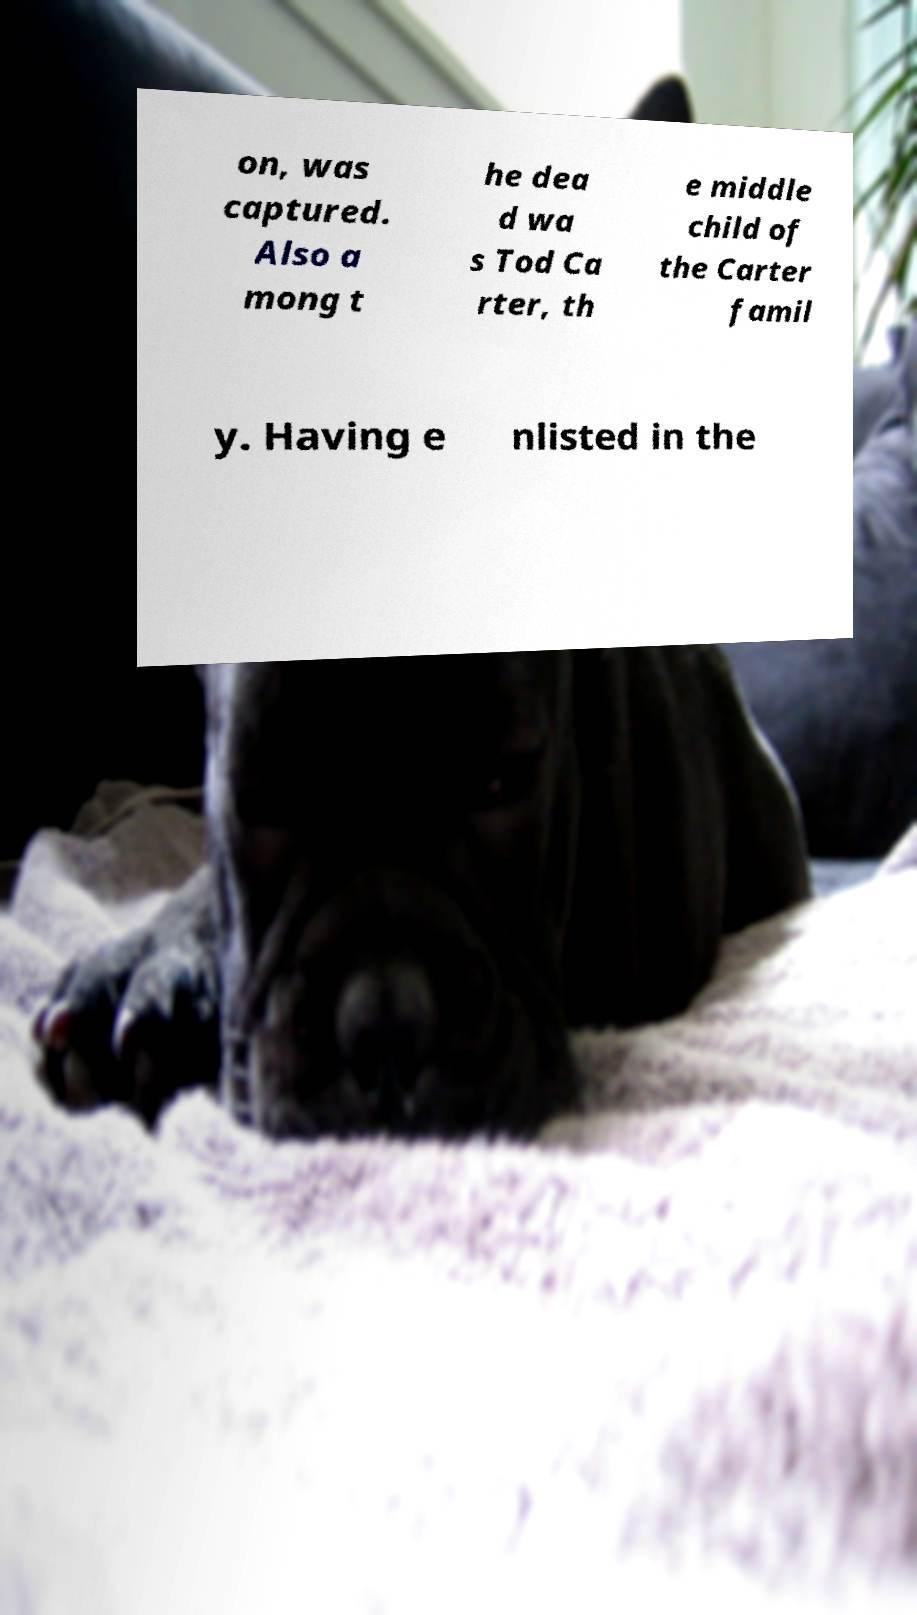Could you assist in decoding the text presented in this image and type it out clearly? on, was captured. Also a mong t he dea d wa s Tod Ca rter, th e middle child of the Carter famil y. Having e nlisted in the 